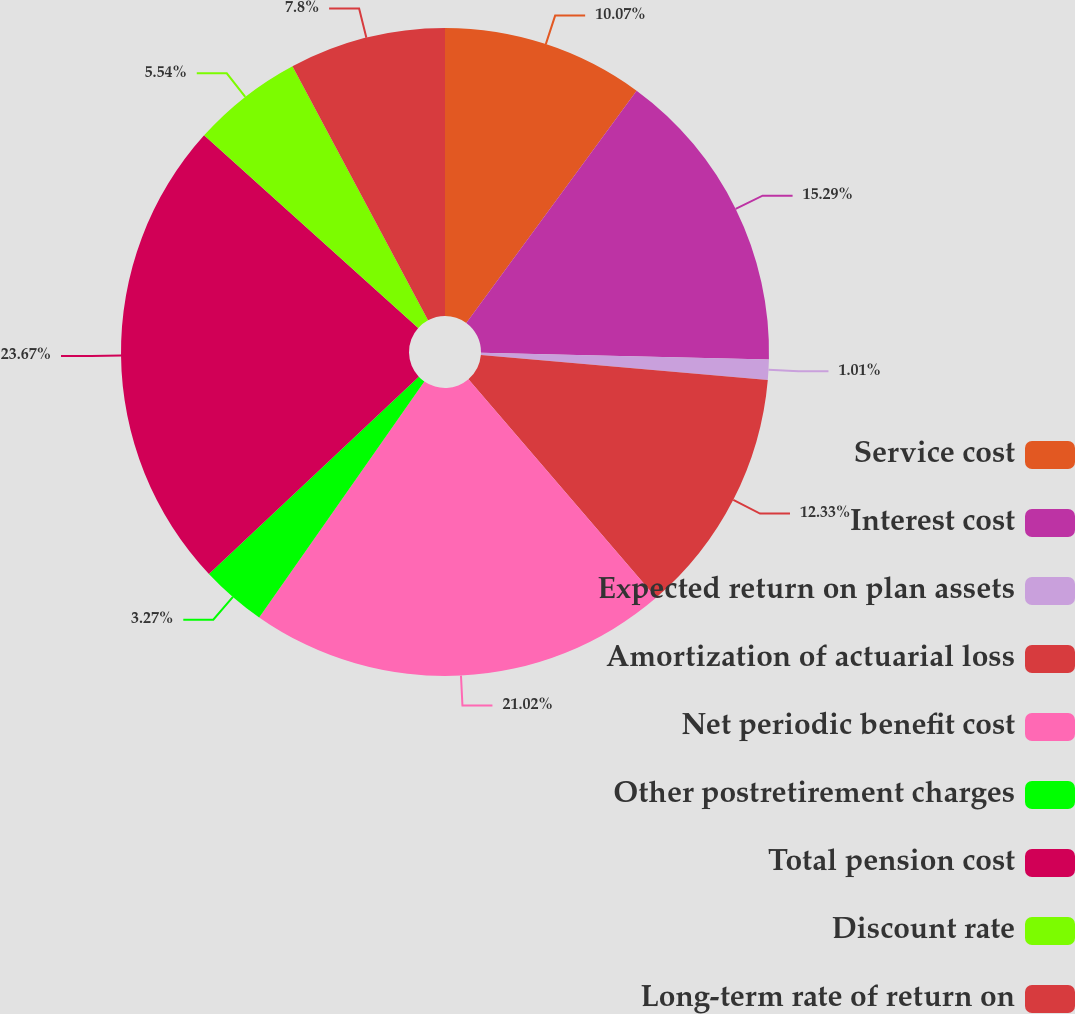<chart> <loc_0><loc_0><loc_500><loc_500><pie_chart><fcel>Service cost<fcel>Interest cost<fcel>Expected return on plan assets<fcel>Amortization of actuarial loss<fcel>Net periodic benefit cost<fcel>Other postretirement charges<fcel>Total pension cost<fcel>Discount rate<fcel>Long-term rate of return on<nl><fcel>10.07%<fcel>15.29%<fcel>1.01%<fcel>12.33%<fcel>21.01%<fcel>3.27%<fcel>23.66%<fcel>5.54%<fcel>7.8%<nl></chart> 